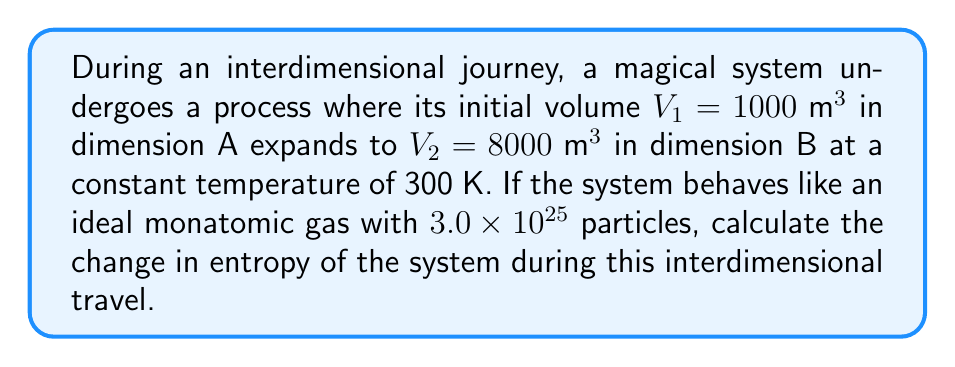Teach me how to tackle this problem. To calculate the change in entropy during this interdimensional travel, we'll use the equation for the entropy change of an ideal gas undergoing an isothermal process:

$$\Delta S = nR \ln\left(\frac{V_2}{V_1}\right)$$

Where:
- $\Delta S$ is the change in entropy
- $n$ is the number of moles of gas
- $R$ is the universal gas constant (8.314 J/(mol·K))
- $V_1$ and $V_2$ are the initial and final volumes

Step 1: Calculate the number of moles
Number of particles = $3.0 \times 10^{25}$
Avogadro's number = $6.022 \times 10^{23}$ particles/mol
$n = \frac{3.0 \times 10^{25}}{6.022 \times 10^{23}} = 49.82 \text{ mol}$

Step 2: Substitute values into the equation
$$\Delta S = (49.82 \text{ mol})(8.314 \text{ J/(mol·K)}) \ln\left(\frac{8000 \text{ m}^3}{1000 \text{ m}^3}\right)$$

Step 3: Simplify
$$\Delta S = 414.19 \text{ J/K} \cdot \ln(8)$$
$$\Delta S = 414.19 \text{ J/K} \cdot 2.0794$$
$$\Delta S = 861.28 \text{ J/K}$$

Therefore, the change in entropy during the interdimensional travel is 861.28 J/K.
Answer: 861.28 J/K 